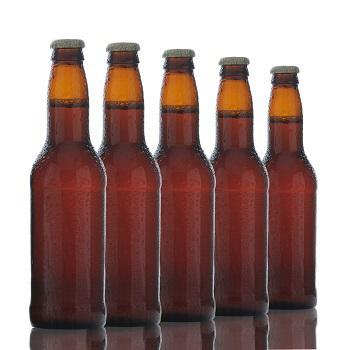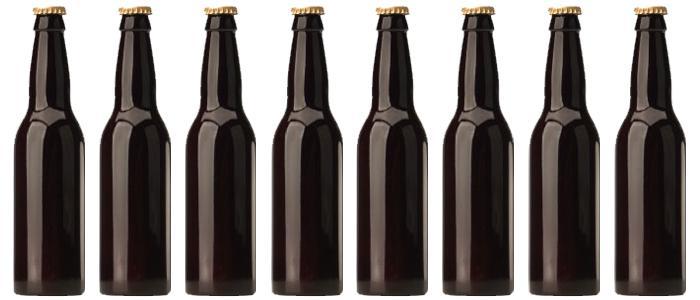The first image is the image on the left, the second image is the image on the right. For the images displayed, is the sentence "The bottles are of two colors and none have lables." factually correct? Answer yes or no. Yes. The first image is the image on the left, the second image is the image on the right. Assess this claim about the two images: "No bottles have labels or metal openers on top.". Correct or not? Answer yes or no. Yes. 